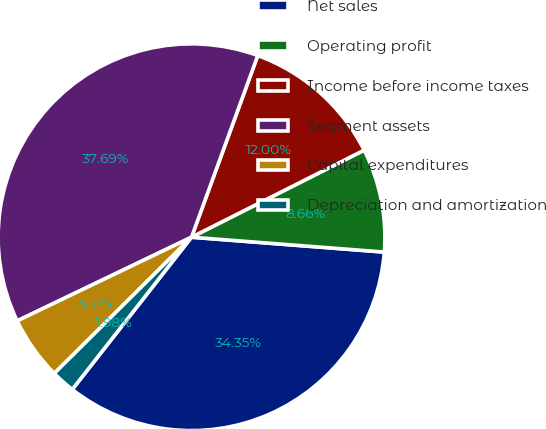Convert chart to OTSL. <chart><loc_0><loc_0><loc_500><loc_500><pie_chart><fcel>Net sales<fcel>Operating profit<fcel>Income before income taxes<fcel>Segment assets<fcel>Capital expenditures<fcel>Depreciation and amortization<nl><fcel>34.35%<fcel>8.66%<fcel>12.0%<fcel>37.69%<fcel>5.32%<fcel>1.98%<nl></chart> 